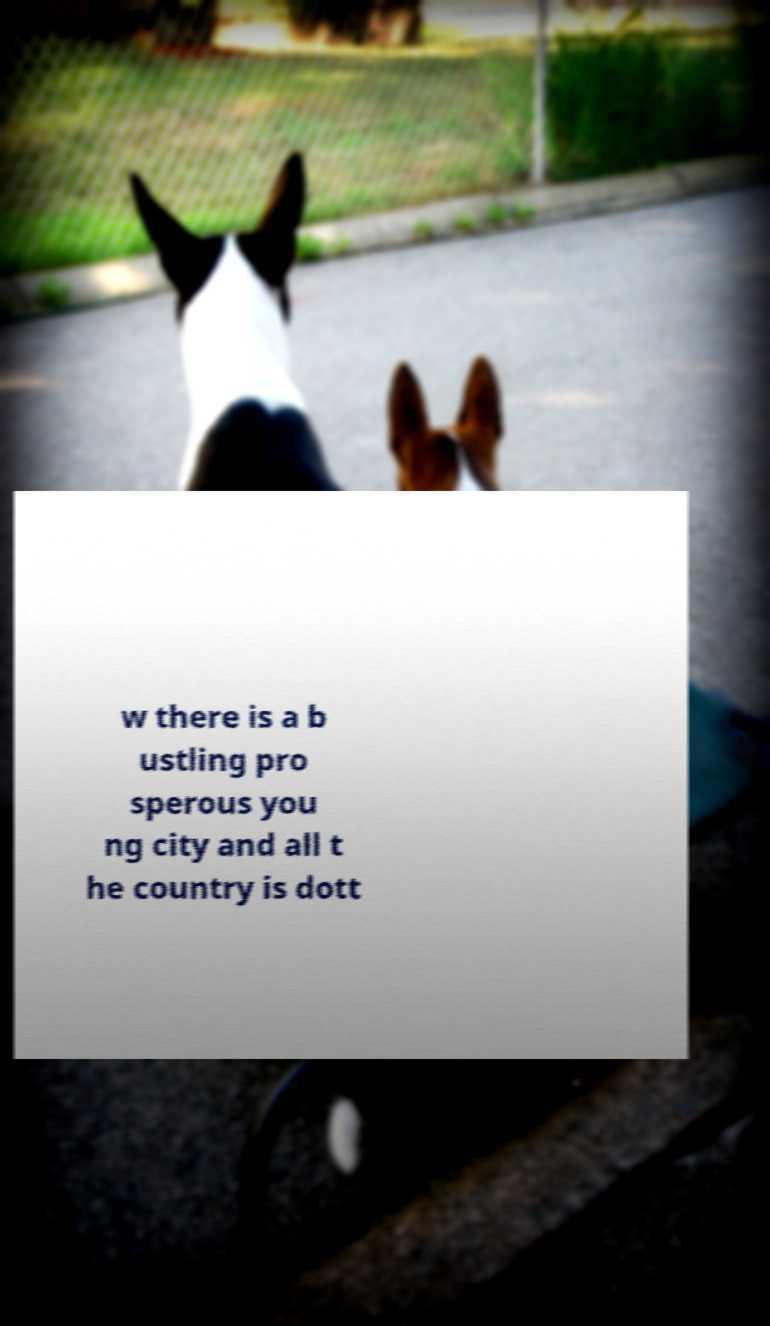Could you assist in decoding the text presented in this image and type it out clearly? w there is a b ustling pro sperous you ng city and all t he country is dott 